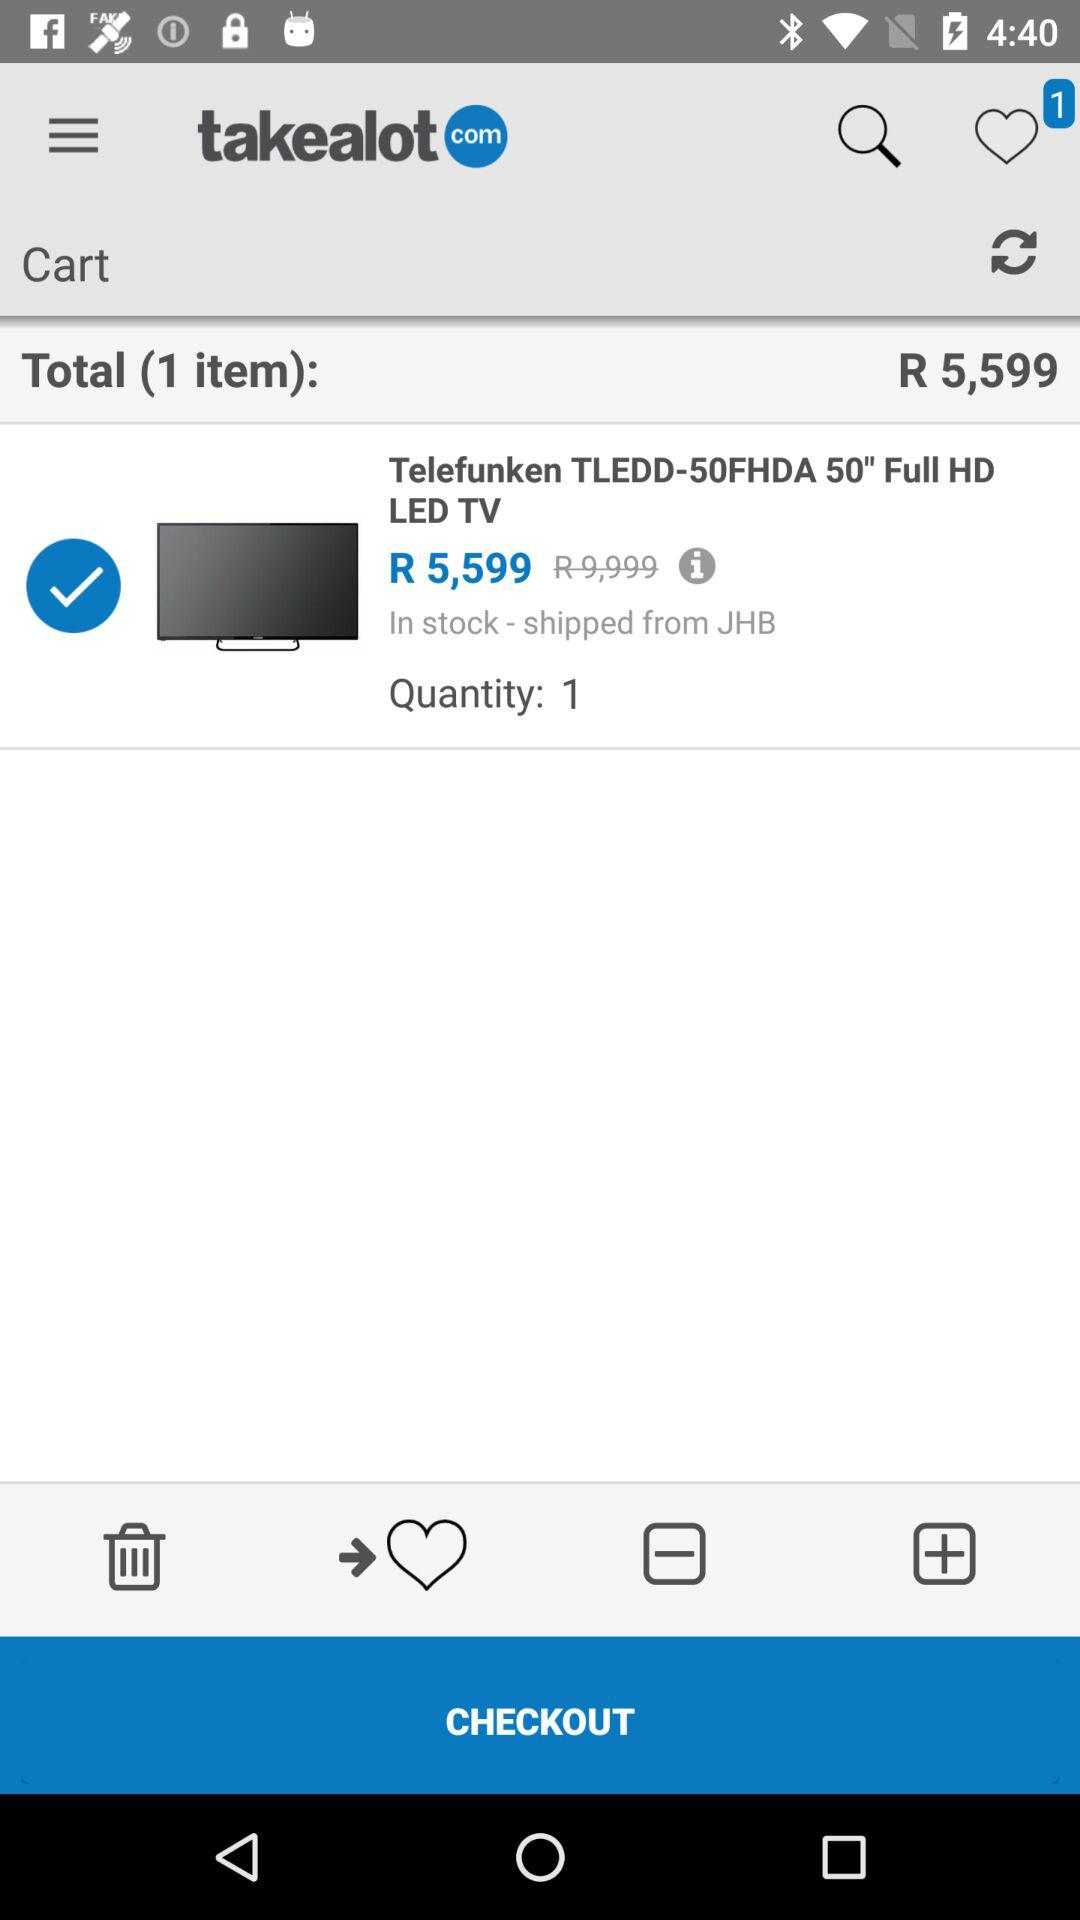Where was it shipped from? It was shipped from JHB. 